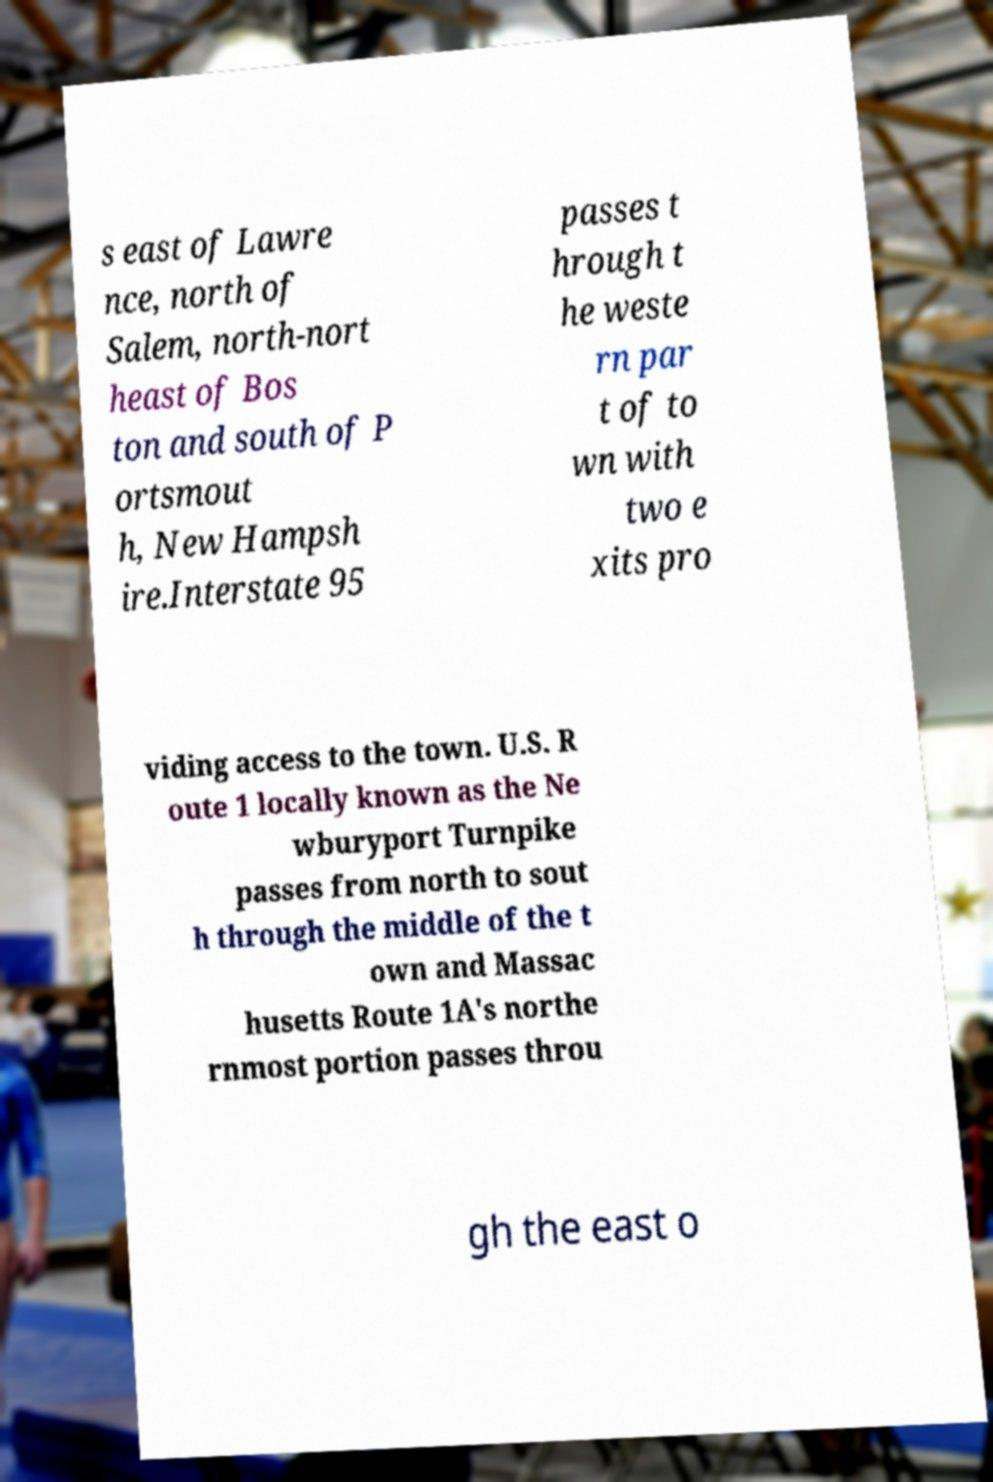Can you read and provide the text displayed in the image?This photo seems to have some interesting text. Can you extract and type it out for me? s east of Lawre nce, north of Salem, north-nort heast of Bos ton and south of P ortsmout h, New Hampsh ire.Interstate 95 passes t hrough t he weste rn par t of to wn with two e xits pro viding access to the town. U.S. R oute 1 locally known as the Ne wburyport Turnpike passes from north to sout h through the middle of the t own and Massac husetts Route 1A's northe rnmost portion passes throu gh the east o 